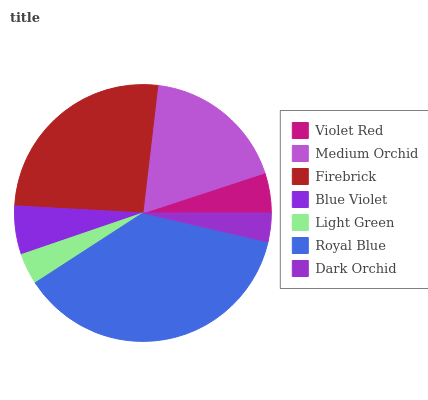Is Dark Orchid the minimum?
Answer yes or no. Yes. Is Royal Blue the maximum?
Answer yes or no. Yes. Is Medium Orchid the minimum?
Answer yes or no. No. Is Medium Orchid the maximum?
Answer yes or no. No. Is Medium Orchid greater than Violet Red?
Answer yes or no. Yes. Is Violet Red less than Medium Orchid?
Answer yes or no. Yes. Is Violet Red greater than Medium Orchid?
Answer yes or no. No. Is Medium Orchid less than Violet Red?
Answer yes or no. No. Is Blue Violet the high median?
Answer yes or no. Yes. Is Blue Violet the low median?
Answer yes or no. Yes. Is Medium Orchid the high median?
Answer yes or no. No. Is Light Green the low median?
Answer yes or no. No. 